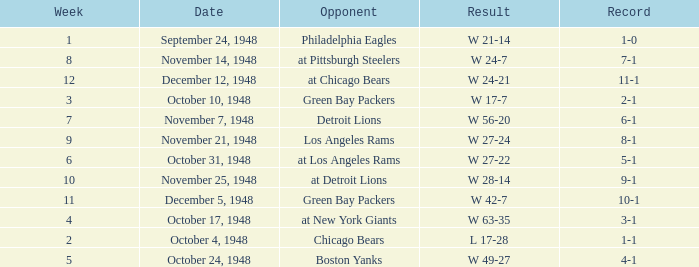What was the record for December 5, 1948? 10-1. 